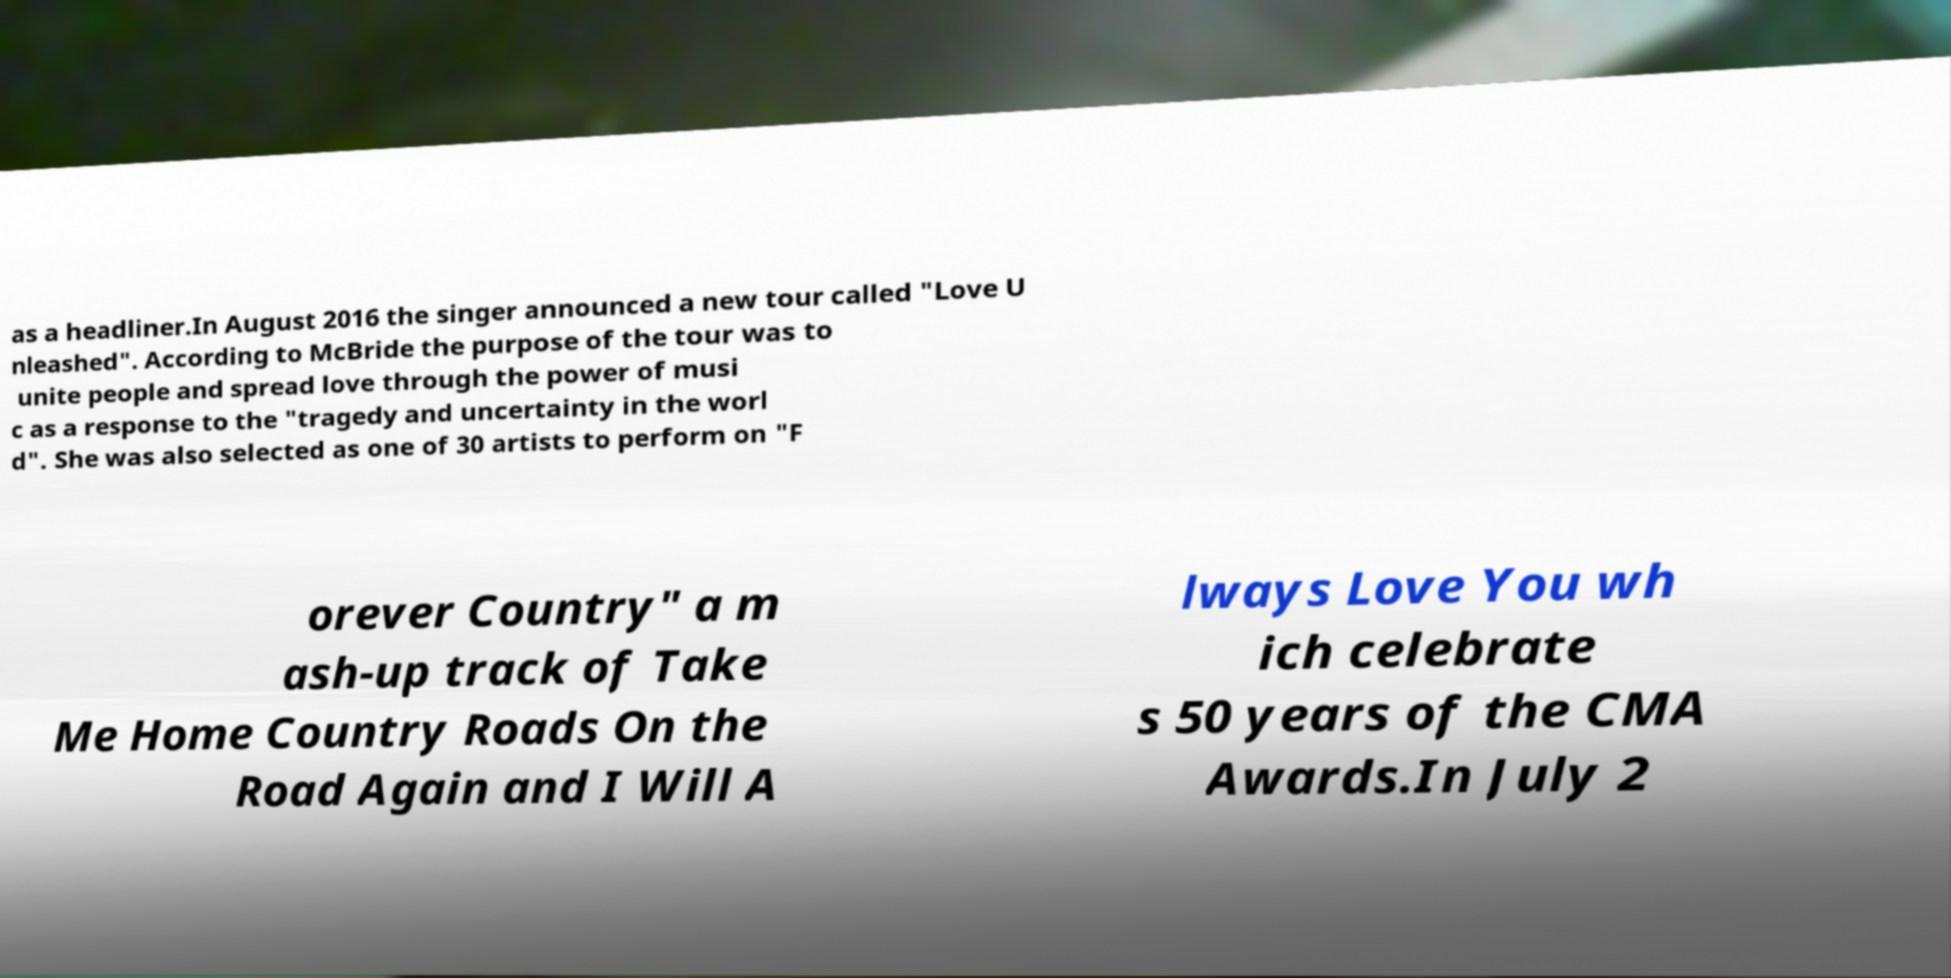Can you read and provide the text displayed in the image?This photo seems to have some interesting text. Can you extract and type it out for me? as a headliner.In August 2016 the singer announced a new tour called "Love U nleashed". According to McBride the purpose of the tour was to unite people and spread love through the power of musi c as a response to the "tragedy and uncertainty in the worl d". She was also selected as one of 30 artists to perform on "F orever Country" a m ash-up track of Take Me Home Country Roads On the Road Again and I Will A lways Love You wh ich celebrate s 50 years of the CMA Awards.In July 2 